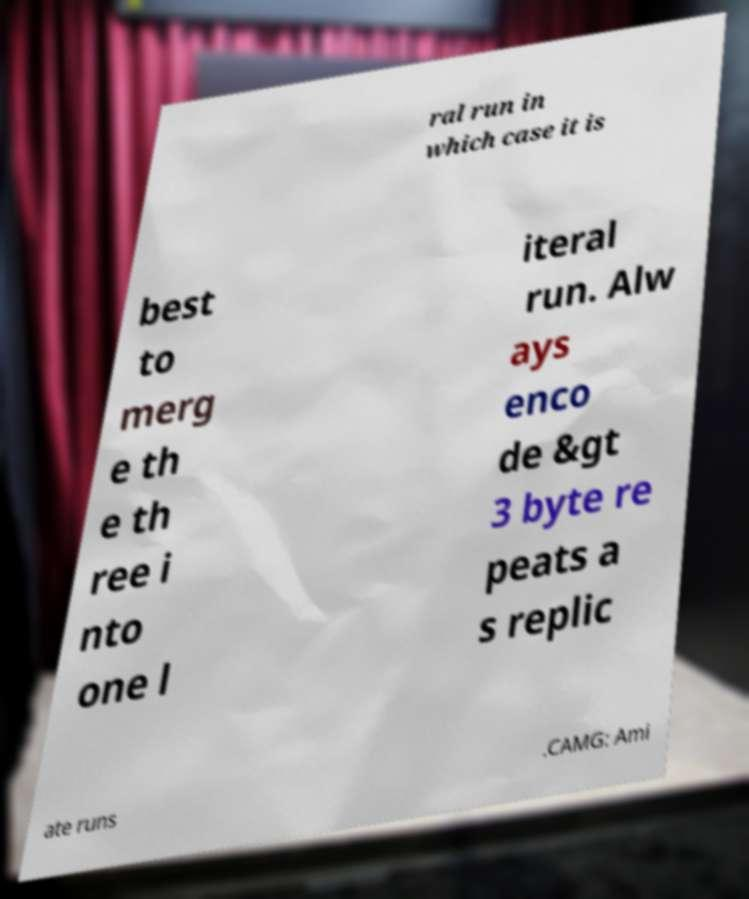For documentation purposes, I need the text within this image transcribed. Could you provide that? ral run in which case it is best to merg e th e th ree i nto one l iteral run. Alw ays enco de &gt 3 byte re peats a s replic ate runs .CAMG: Ami 